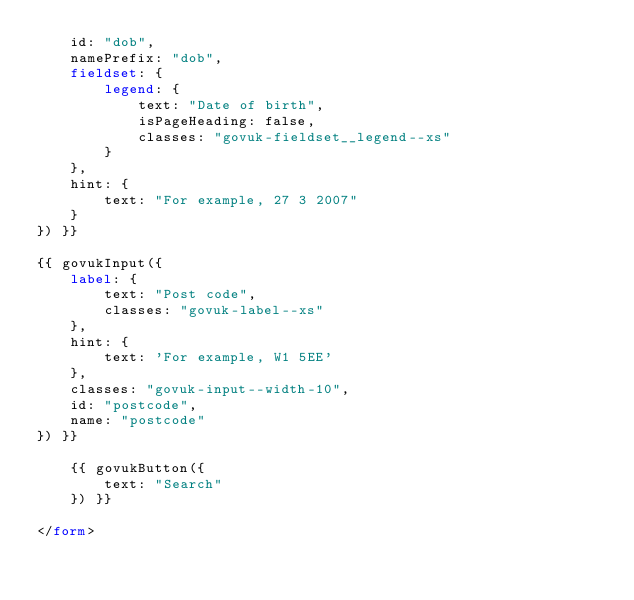<code> <loc_0><loc_0><loc_500><loc_500><_HTML_>    id: "dob",
    namePrefix: "dob",
    fieldset: {
        legend: {
            text: "Date of birth",
            isPageHeading: false,
            classes: "govuk-fieldset__legend--xs"
        }
    },
    hint: {
        text: "For example, 27 3 2007"
    }
}) }}

{{ govukInput({
    label: {
        text: "Post code",
        classes: "govuk-label--xs"
    },
    hint: {
        text: 'For example, W1 5EE'
    },
    classes: "govuk-input--width-10",
    id: "postcode",
    name: "postcode"
}) }}

    {{ govukButton({
        text: "Search"
    }) }}

</form></code> 